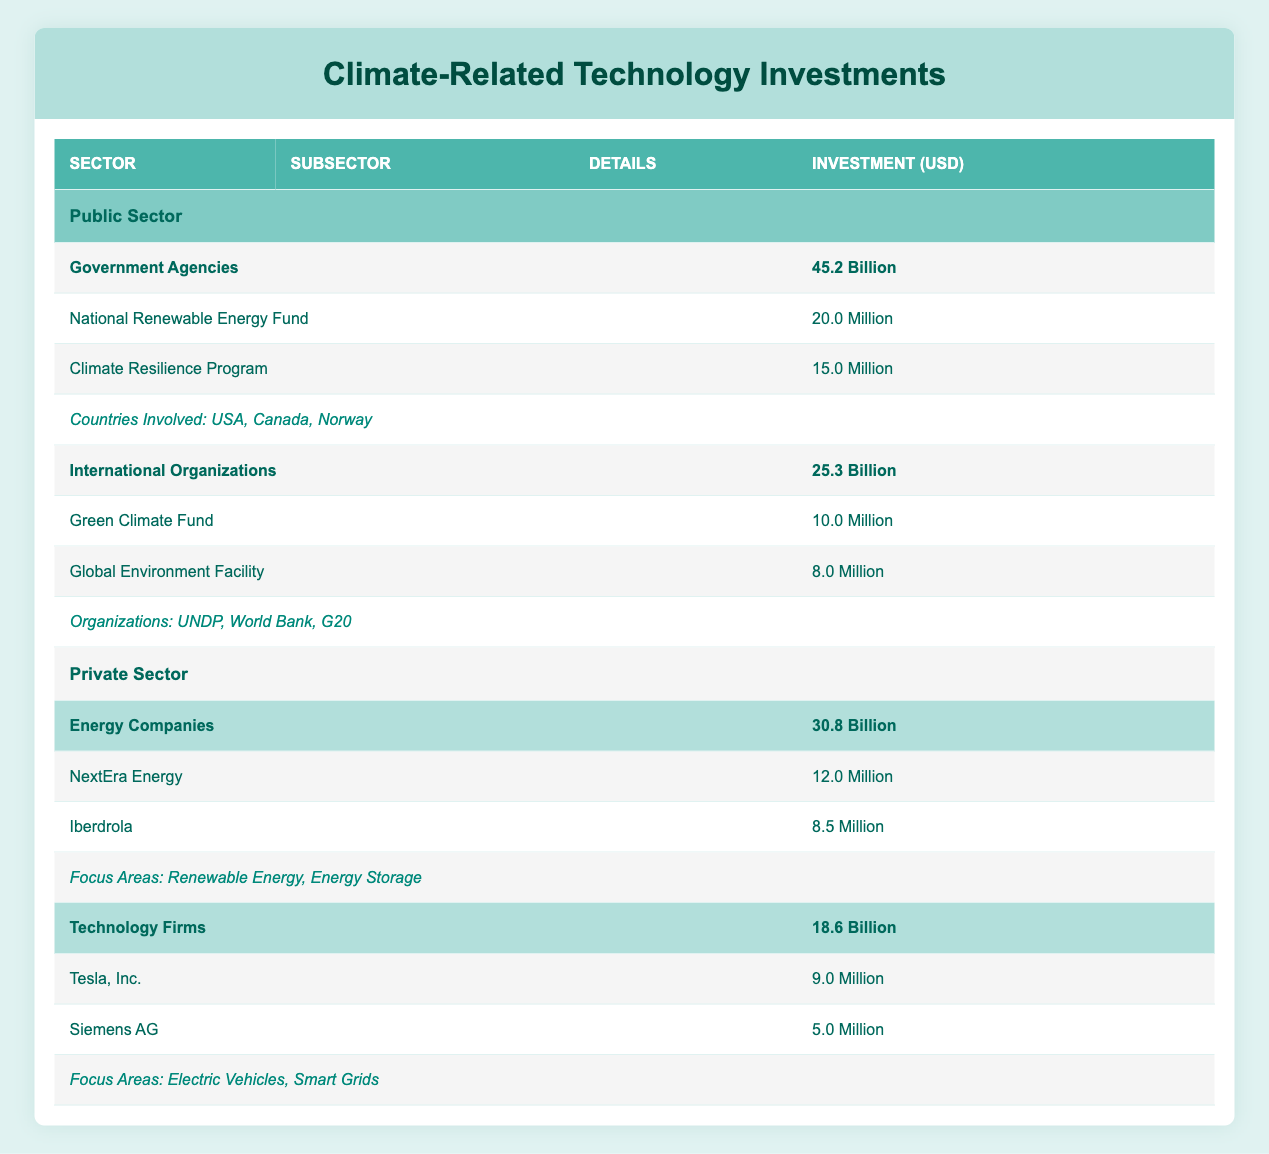What is the total investment from the public sector? The table shows two subsectors under the public sector: Government Agencies (45.2 billion) and International Organizations (25.3 billion). To find the total investment from the public sector, we sum these two amounts: 45.2 + 25.3 = 70.5 billion.
Answer: 70.5 billion How much did the Climate Resilience Program receive? The table provides direct information under the Government Agencies subsector, listing Climate Resilience Program with an investment of 15 million. Therefore, this is the amount received by the Climate Resilience Program.
Answer: 15 million Did international organizations have a larger investment than energy companies? Comparing the investments listed, international organizations had an investment of 25.3 billion, while energy companies had an investment of 30.8 billion. Since 30.8 billion is greater than 25.3 billion, the statement is false.
Answer: No What is the total investment in climate-related technologies by the private sector? The private sector includes two subsectors: Energy Companies with 30.8 billion and Technology Firms with 18.6 billion. To find the total investment in the private sector, we sum these: 30.8 + 18.6 = 49.4 billion.
Answer: 49.4 billion Which international organization contributed the most to climate-related investments? The table lists two key programs under International Organizations: Green Climate Fund (10 million) and Global Environment Facility (8 million). Comparing these two, the Green Climate Fund received the most at 10 million.
Answer: Green Climate Fund What are the focus areas for private sector investments in technology firms? The table specifies under Technology Firms that the focus areas are Electric Vehicles and Smart Grids. These are the sectors in which technology firms are investing.
Answer: Electric Vehicles and Smart Grids What is the total investment for the key programs under government agencies? Under the Government Agencies subsection, the key programs are National Renewable Energy Fund (20 million) and Climate Resilience Program (15 million). To find the total, we add the two: 20 + 15 = 35 million.
Answer: 35 million Is NextEra Energy one of the top companies featured in the private sector investment table? The table directly lists NextEra Energy under Energy Companies, confirming its presence as a key company featured in the investment data.
Answer: Yes Which country is not mentioned in the countries involved under the public sector? The countries involved listed in the Government Agencies section are USA, Canada, and Norway. To answer this, we can check for any missing country that isn’t listed among these three. If given other common countries, we can deduce which one is not mentioned.
Answer: Varies based on external knowledge 